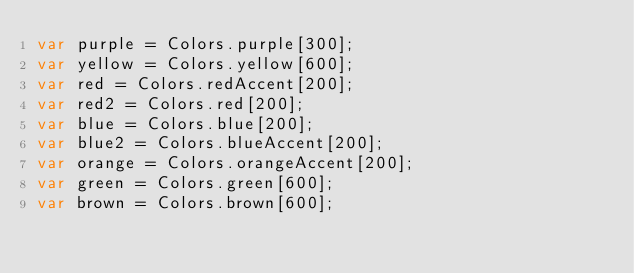Convert code to text. <code><loc_0><loc_0><loc_500><loc_500><_Dart_>var purple = Colors.purple[300];
var yellow = Colors.yellow[600];
var red = Colors.redAccent[200];
var red2 = Colors.red[200];
var blue = Colors.blue[200];
var blue2 = Colors.blueAccent[200];
var orange = Colors.orangeAccent[200];
var green = Colors.green[600];
var brown = Colors.brown[600];
</code> 